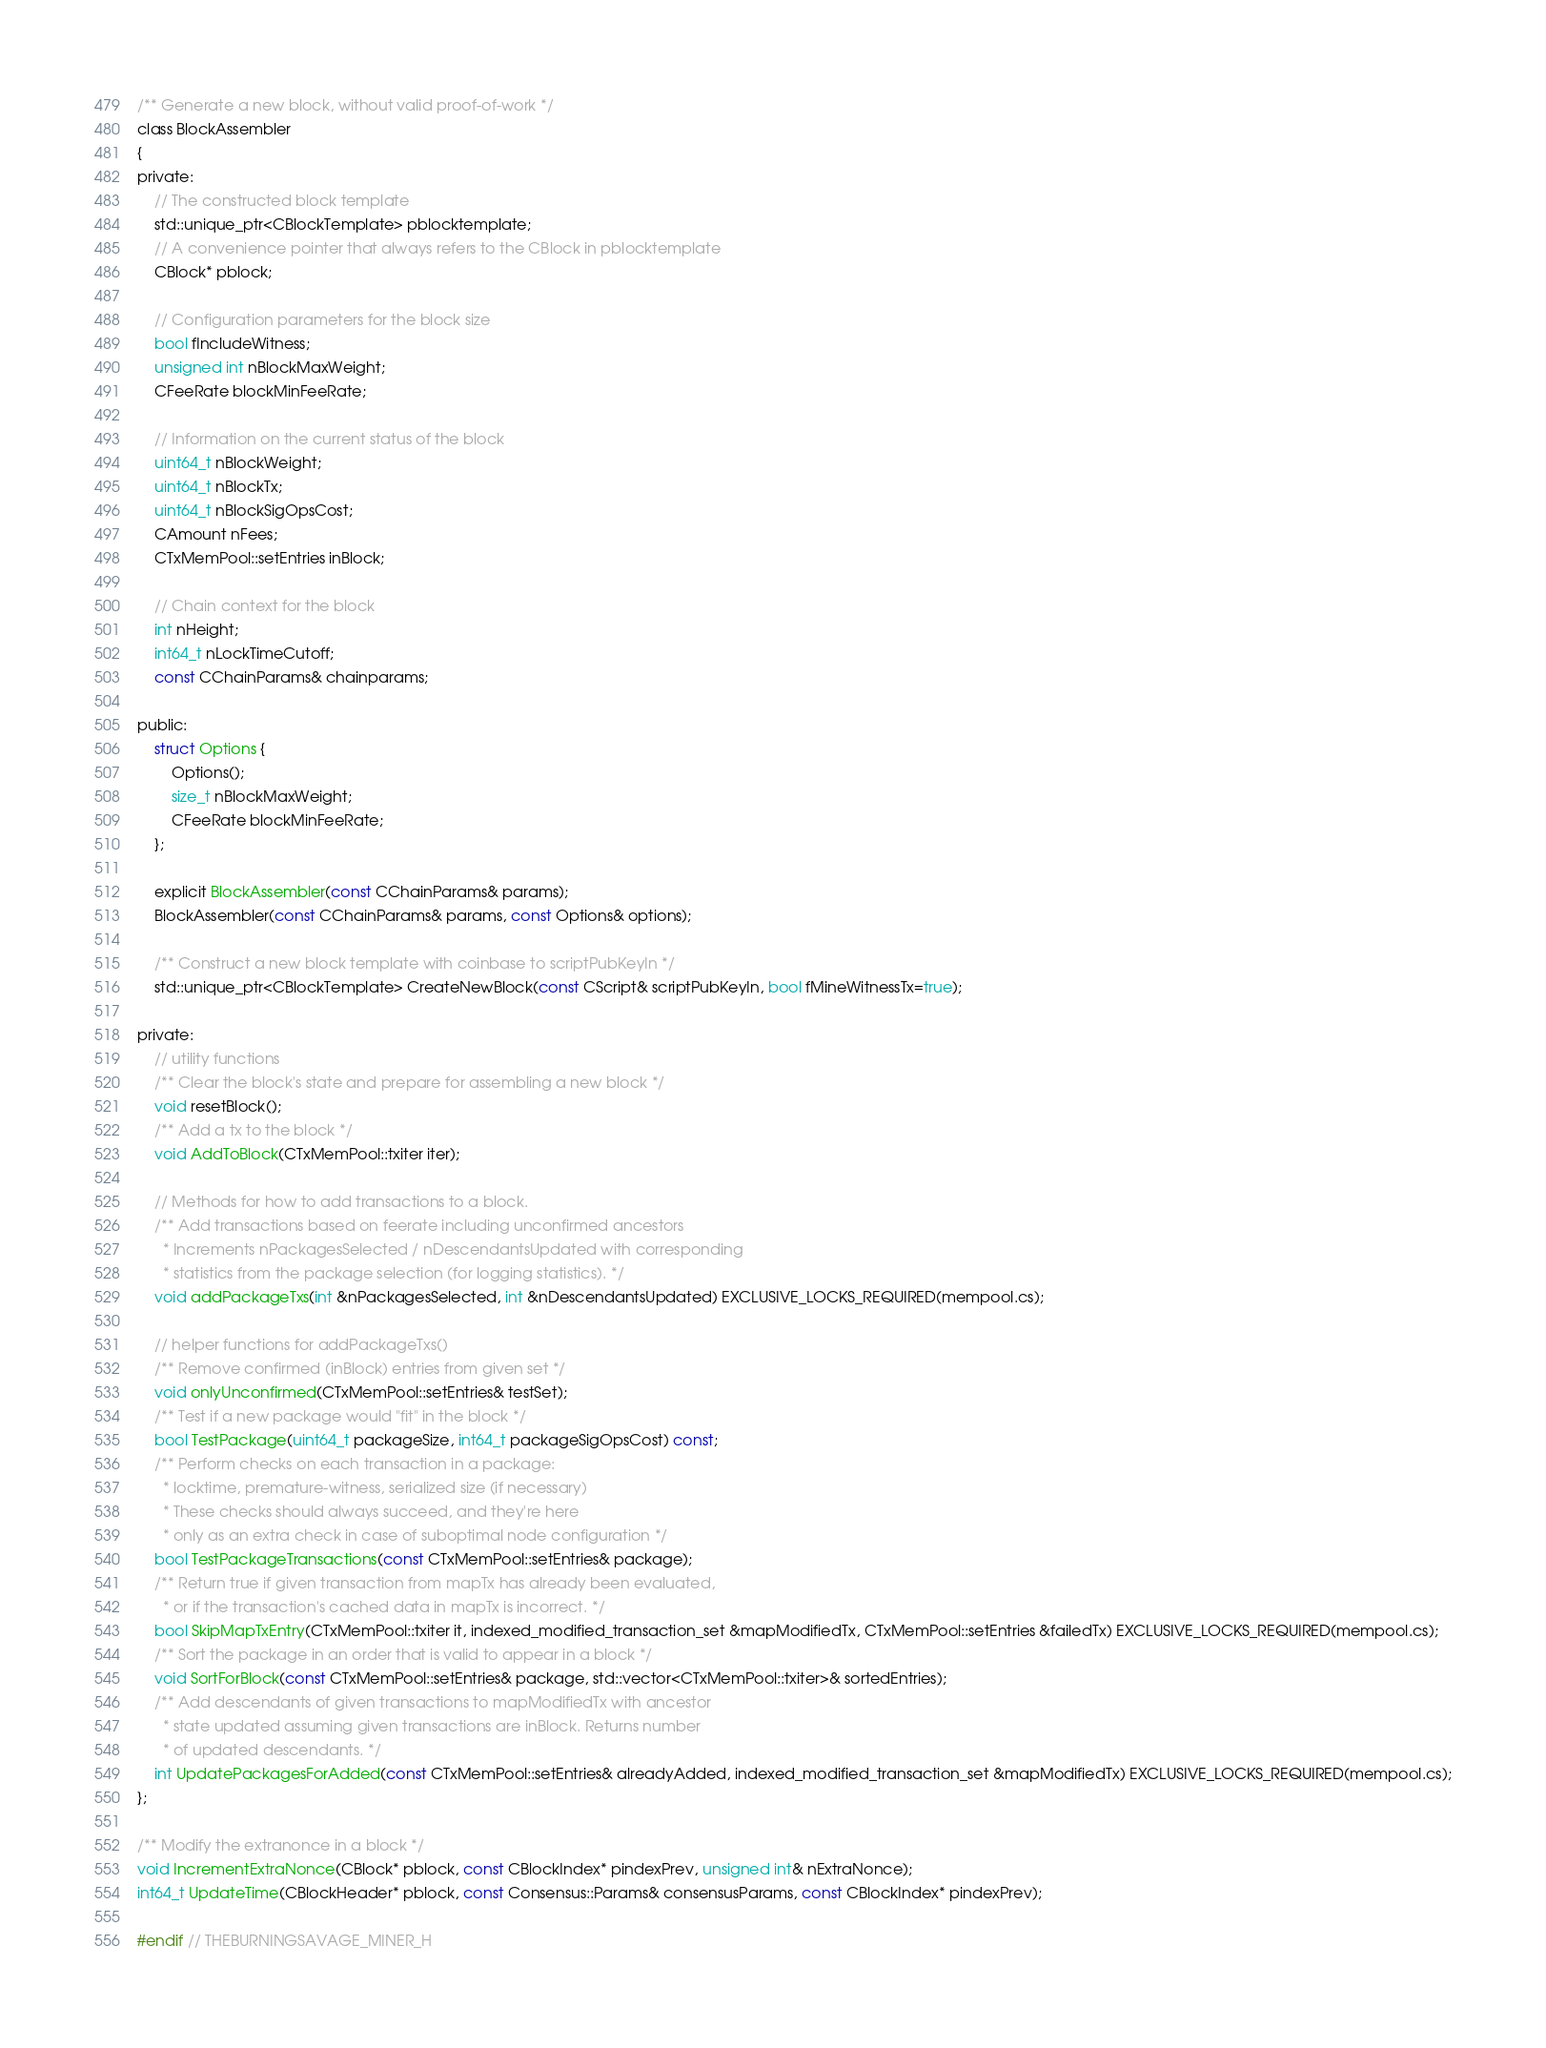Convert code to text. <code><loc_0><loc_0><loc_500><loc_500><_C_>/** Generate a new block, without valid proof-of-work */
class BlockAssembler
{
private:
    // The constructed block template
    std::unique_ptr<CBlockTemplate> pblocktemplate;
    // A convenience pointer that always refers to the CBlock in pblocktemplate
    CBlock* pblock;

    // Configuration parameters for the block size
    bool fIncludeWitness;
    unsigned int nBlockMaxWeight;
    CFeeRate blockMinFeeRate;

    // Information on the current status of the block
    uint64_t nBlockWeight;
    uint64_t nBlockTx;
    uint64_t nBlockSigOpsCost;
    CAmount nFees;
    CTxMemPool::setEntries inBlock;

    // Chain context for the block
    int nHeight;
    int64_t nLockTimeCutoff;
    const CChainParams& chainparams;

public:
    struct Options {
        Options();
        size_t nBlockMaxWeight;
        CFeeRate blockMinFeeRate;
    };

    explicit BlockAssembler(const CChainParams& params);
    BlockAssembler(const CChainParams& params, const Options& options);

    /** Construct a new block template with coinbase to scriptPubKeyIn */
    std::unique_ptr<CBlockTemplate> CreateNewBlock(const CScript& scriptPubKeyIn, bool fMineWitnessTx=true);

private:
    // utility functions
    /** Clear the block's state and prepare for assembling a new block */
    void resetBlock();
    /** Add a tx to the block */
    void AddToBlock(CTxMemPool::txiter iter);

    // Methods for how to add transactions to a block.
    /** Add transactions based on feerate including unconfirmed ancestors
      * Increments nPackagesSelected / nDescendantsUpdated with corresponding
      * statistics from the package selection (for logging statistics). */
    void addPackageTxs(int &nPackagesSelected, int &nDescendantsUpdated) EXCLUSIVE_LOCKS_REQUIRED(mempool.cs);

    // helper functions for addPackageTxs()
    /** Remove confirmed (inBlock) entries from given set */
    void onlyUnconfirmed(CTxMemPool::setEntries& testSet);
    /** Test if a new package would "fit" in the block */
    bool TestPackage(uint64_t packageSize, int64_t packageSigOpsCost) const;
    /** Perform checks on each transaction in a package:
      * locktime, premature-witness, serialized size (if necessary)
      * These checks should always succeed, and they're here
      * only as an extra check in case of suboptimal node configuration */
    bool TestPackageTransactions(const CTxMemPool::setEntries& package);
    /** Return true if given transaction from mapTx has already been evaluated,
      * or if the transaction's cached data in mapTx is incorrect. */
    bool SkipMapTxEntry(CTxMemPool::txiter it, indexed_modified_transaction_set &mapModifiedTx, CTxMemPool::setEntries &failedTx) EXCLUSIVE_LOCKS_REQUIRED(mempool.cs);
    /** Sort the package in an order that is valid to appear in a block */
    void SortForBlock(const CTxMemPool::setEntries& package, std::vector<CTxMemPool::txiter>& sortedEntries);
    /** Add descendants of given transactions to mapModifiedTx with ancestor
      * state updated assuming given transactions are inBlock. Returns number
      * of updated descendants. */
    int UpdatePackagesForAdded(const CTxMemPool::setEntries& alreadyAdded, indexed_modified_transaction_set &mapModifiedTx) EXCLUSIVE_LOCKS_REQUIRED(mempool.cs);
};

/** Modify the extranonce in a block */
void IncrementExtraNonce(CBlock* pblock, const CBlockIndex* pindexPrev, unsigned int& nExtraNonce);
int64_t UpdateTime(CBlockHeader* pblock, const Consensus::Params& consensusParams, const CBlockIndex* pindexPrev);

#endif // THEBURNINGSAVAGE_MINER_H
</code> 